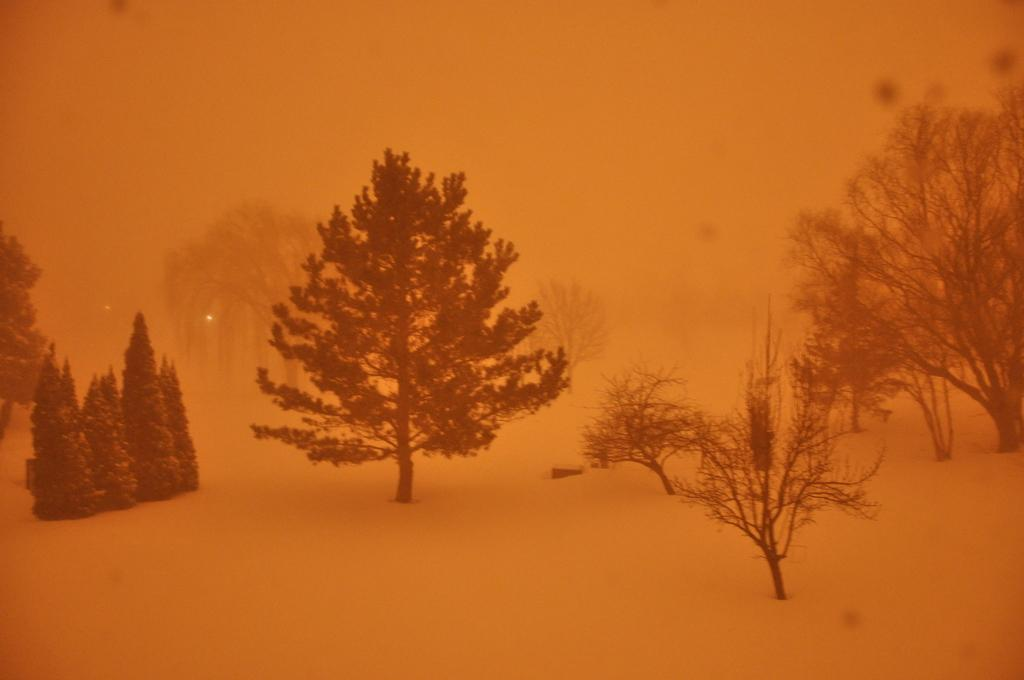What type of vegetation can be seen in the image? There are trees in the image. What atmospheric condition is visible in the background of the image? There is fog visible in the background of the image. How many babies are present in the image? There are no babies present in the image. What is the zinc content of the fog in the image? There is no information about the zinc content of the fog in the image, and it is not possible to determine this from the image alone. 